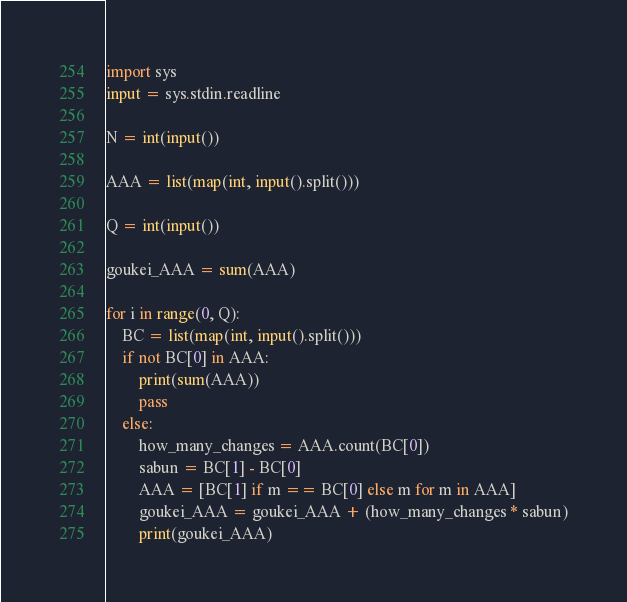<code> <loc_0><loc_0><loc_500><loc_500><_Python_>import sys
input = sys.stdin.readline

N = int(input())

AAA = list(map(int, input().split()))

Q = int(input())

goukei_AAA = sum(AAA)

for i in range(0, Q):
    BC = list(map(int, input().split()))
    if not BC[0] in AAA:
        print(sum(AAA))
        pass
    else:
        how_many_changes = AAA.count(BC[0])
        sabun = BC[1] - BC[0]
        AAA = [BC[1] if m == BC[0] else m for m in AAA]
        goukei_AAA = goukei_AAA + (how_many_changes * sabun)
        print(goukei_AAA)
</code> 